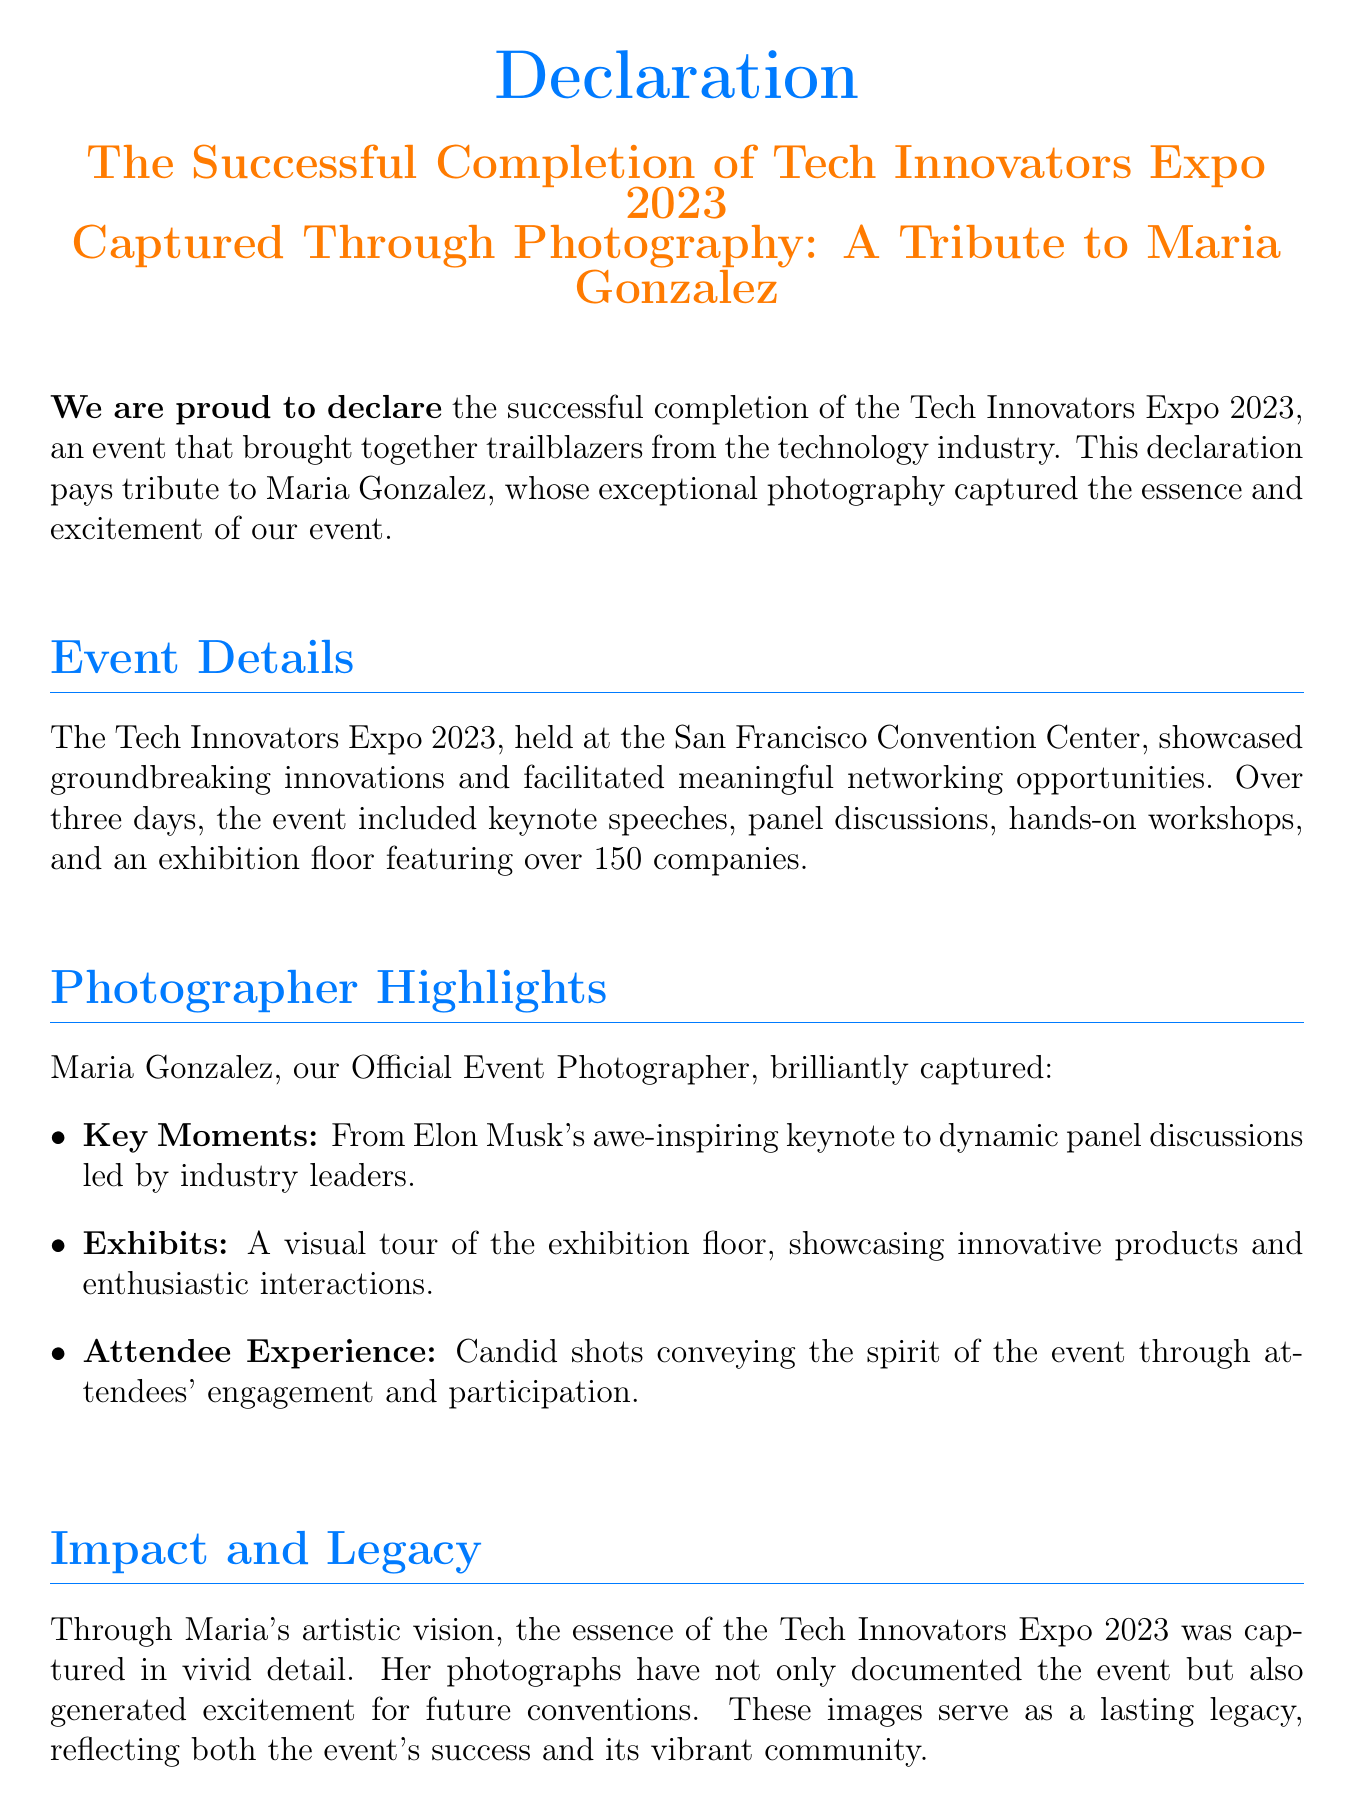What is the name of the event? The event is titled "Tech Innovators Expo 2023," as stated in the declaration.
Answer: Tech Innovators Expo 2023 Who is the official photographer? The document mentions Maria Gonzalez as the official photographer for the event.
Answer: Maria Gonzalez How many companies exhibited at the event? The document specifies that over 150 companies showcased their products during the event.
Answer: Over 150 Where was the event held? The location of the event, as mentioned in the document, is the San Francisco Convention Center.
Answer: San Francisco Convention Center What type of activities were included in the event? The event included keynote speeches, panel discussions, and hands-on workshops, noted in the event details.
Answer: Keynote speeches, panel discussions, hands-on workshops What was one of Maria Gonzalez's photography highlights? The document lists various highlights, including capturing key moments such as Elon Musk's keynote speech.
Answer: Elon Musk's keynote What impact did the photography have on future conventions? The photographs generated excitement for future conventions, as stated in the impact section.
Answer: Generated excitement What is the closing sentiment expressed in the declaration? The closing statement conveys gratitude towards the photographer for capturing the event's essence.
Answer: Gratitude towards the photographer 